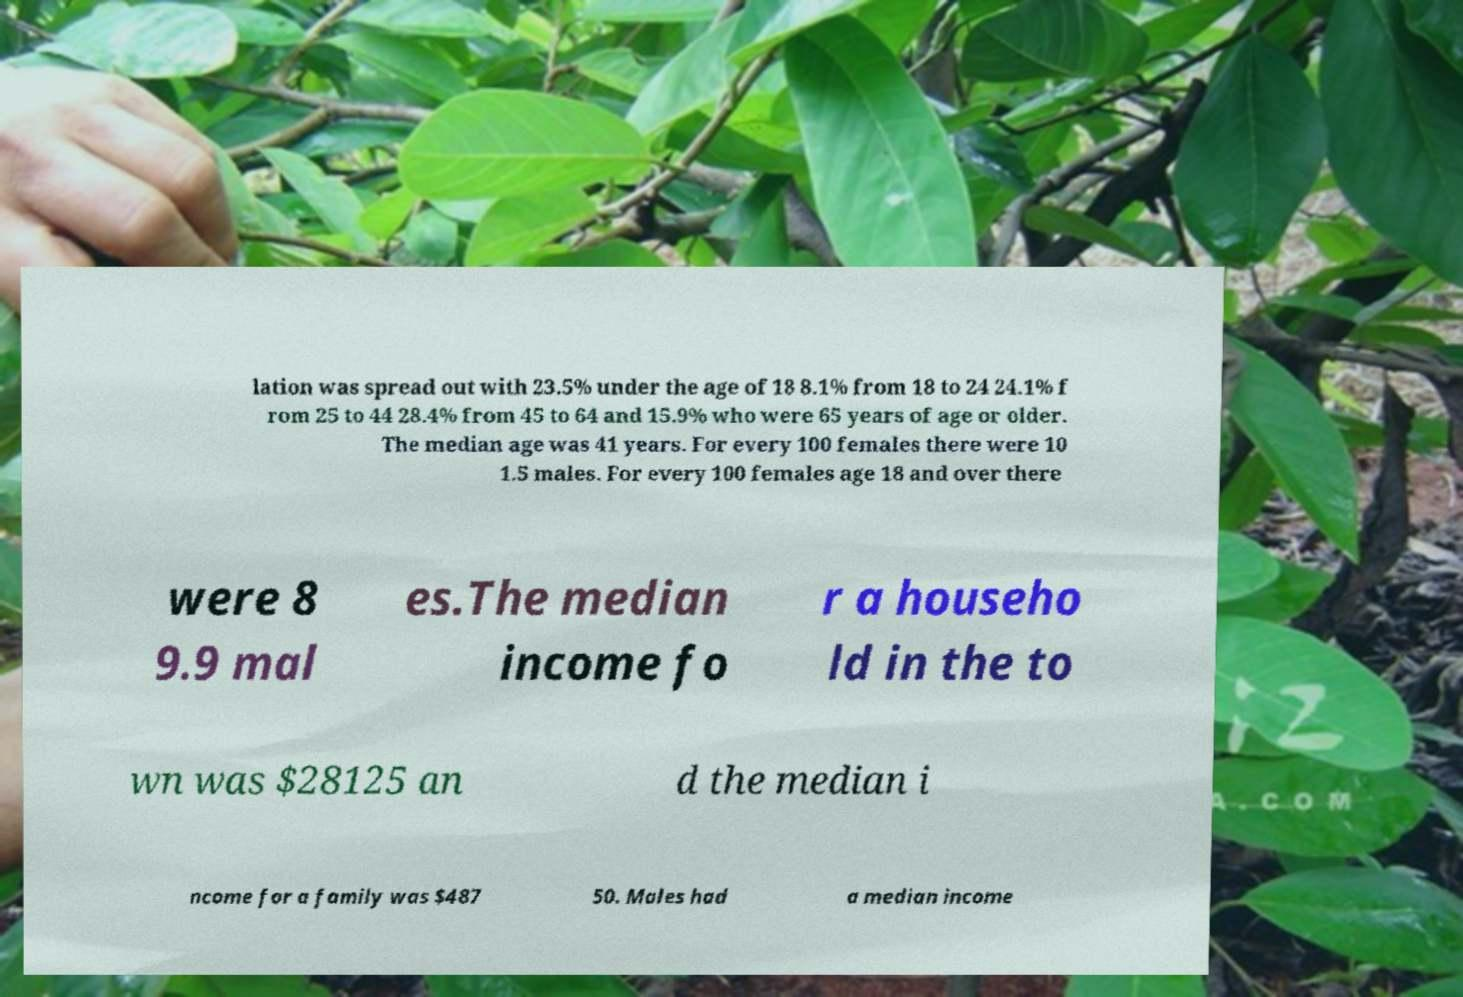What messages or text are displayed in this image? I need them in a readable, typed format. lation was spread out with 23.5% under the age of 18 8.1% from 18 to 24 24.1% f rom 25 to 44 28.4% from 45 to 64 and 15.9% who were 65 years of age or older. The median age was 41 years. For every 100 females there were 10 1.5 males. For every 100 females age 18 and over there were 8 9.9 mal es.The median income fo r a househo ld in the to wn was $28125 an d the median i ncome for a family was $487 50. Males had a median income 